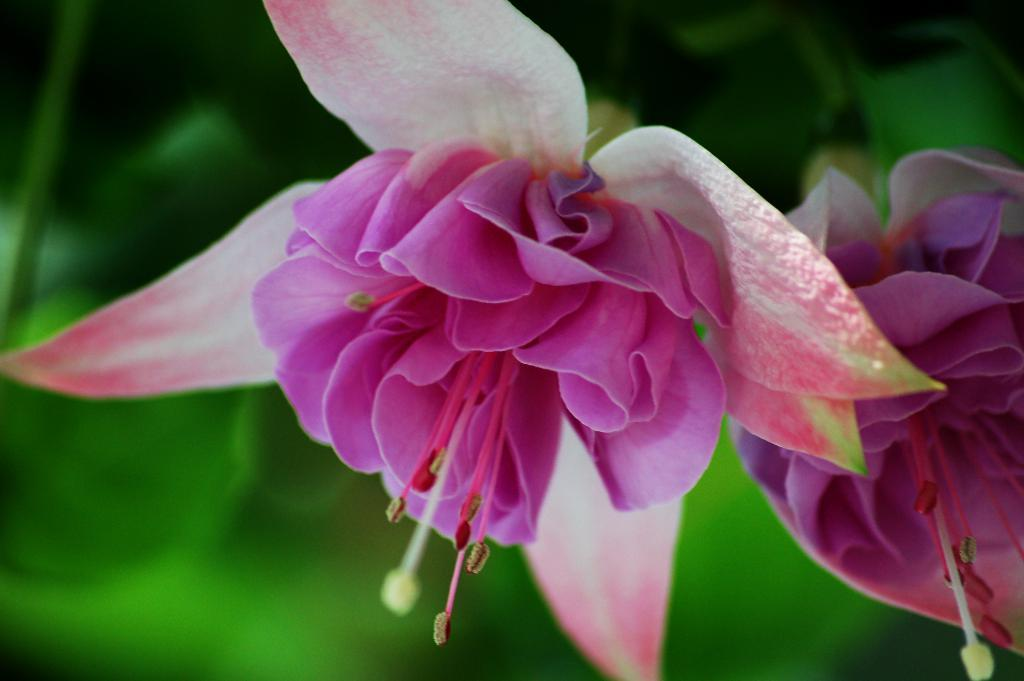What type of living organisms can be seen in the image? There are flowers in the image. Can you describe the background of the image? The background of the image is blurred. How many toes can be seen on the flowers in the image? Flowers do not have toes, so this question cannot be answered. 